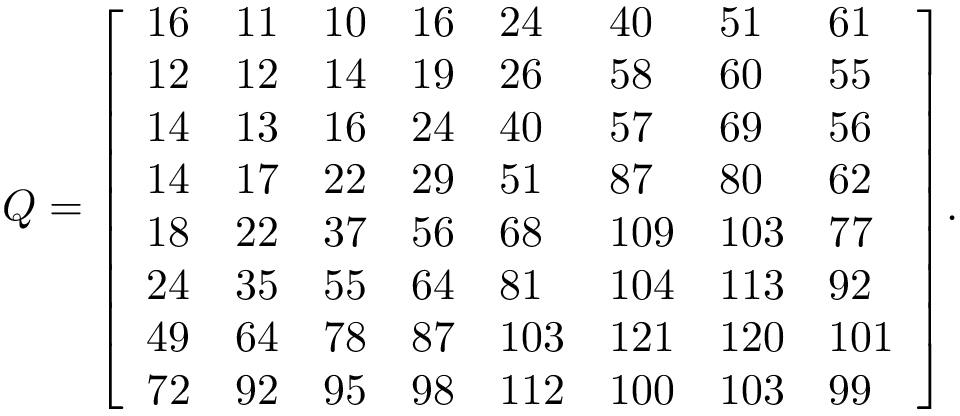Convert formula to latex. <formula><loc_0><loc_0><loc_500><loc_500>Q = { \left [ \begin{array} { l l l l l l l l } { 1 6 } & { 1 1 } & { 1 0 } & { 1 6 } & { 2 4 } & { 4 0 } & { 5 1 } & { 6 1 } \\ { 1 2 } & { 1 2 } & { 1 4 } & { 1 9 } & { 2 6 } & { 5 8 } & { 6 0 } & { 5 5 } \\ { 1 4 } & { 1 3 } & { 1 6 } & { 2 4 } & { 4 0 } & { 5 7 } & { 6 9 } & { 5 6 } \\ { 1 4 } & { 1 7 } & { 2 2 } & { 2 9 } & { 5 1 } & { 8 7 } & { 8 0 } & { 6 2 } \\ { 1 8 } & { 2 2 } & { 3 7 } & { 5 6 } & { 6 8 } & { 1 0 9 } & { 1 0 3 } & { 7 7 } \\ { 2 4 } & { 3 5 } & { 5 5 } & { 6 4 } & { 8 1 } & { 1 0 4 } & { 1 1 3 } & { 9 2 } \\ { 4 9 } & { 6 4 } & { 7 8 } & { 8 7 } & { 1 0 3 } & { 1 2 1 } & { 1 2 0 } & { 1 0 1 } \\ { 7 2 } & { 9 2 } & { 9 5 } & { 9 8 } & { 1 1 2 } & { 1 0 0 } & { 1 0 3 } & { 9 9 } \end{array} \right ] } .</formula> 